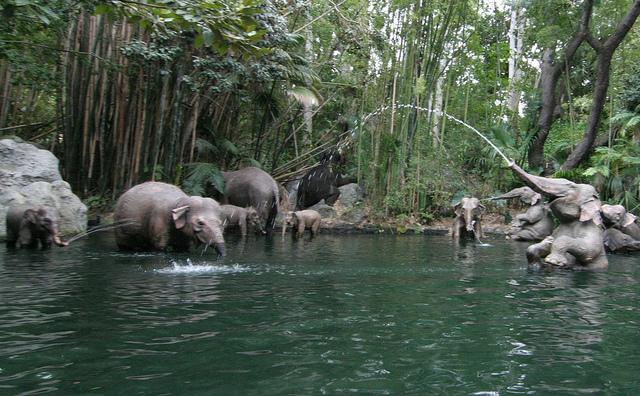Is the elephant shooting the water?
Give a very brief answer. Yes. Are these elephants in their natural habitat?
Write a very short answer. Yes. How many elephants are there?
Give a very brief answer. 8. Are the elephants playing?
Keep it brief. Yes. 